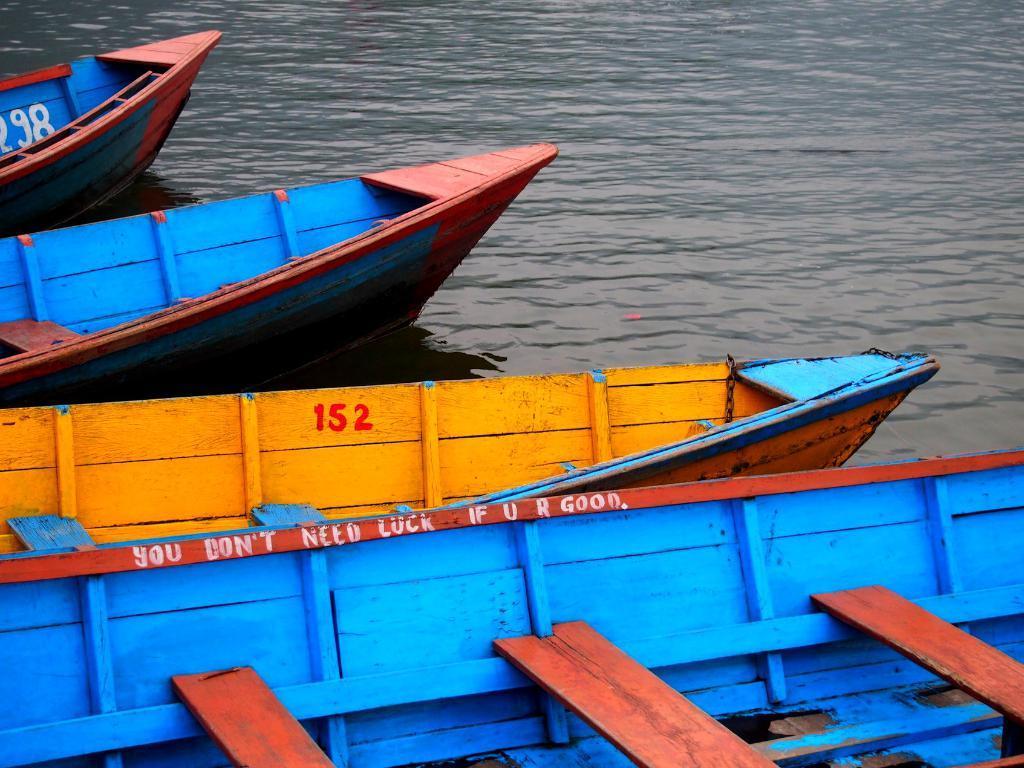Describe this image in one or two sentences. In this picture we can see four boats and these boats are on the water. 